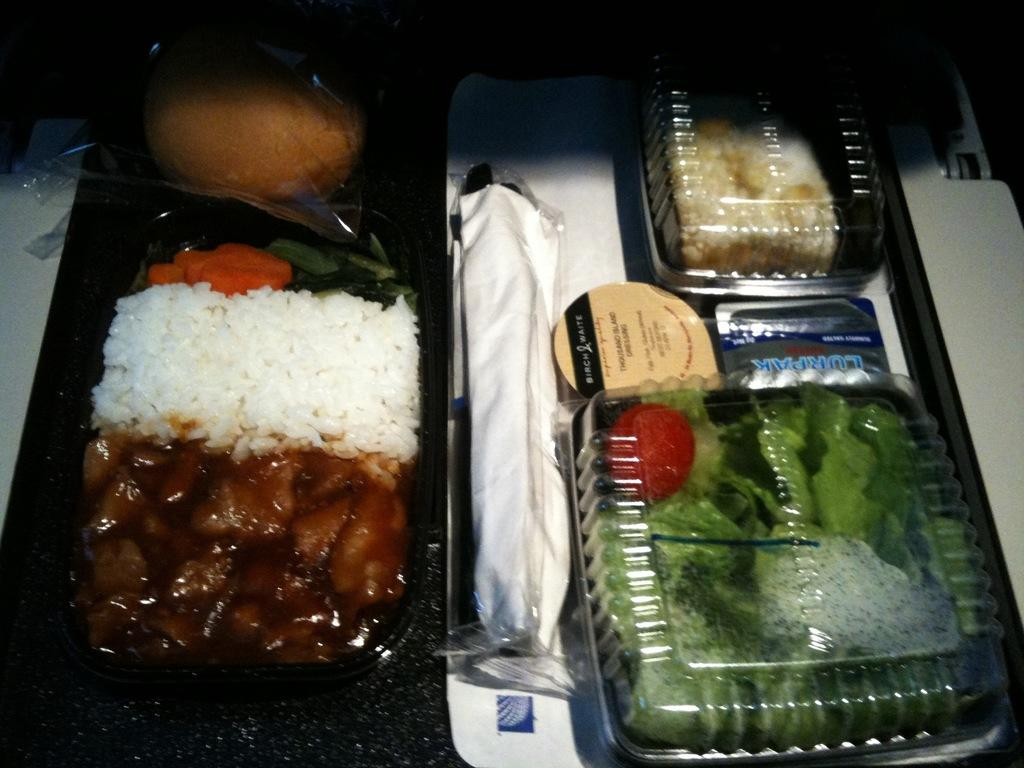Provide a one-sentence caption for the provided image. A container of thousand island dressing sits on the tray next to a salad. 